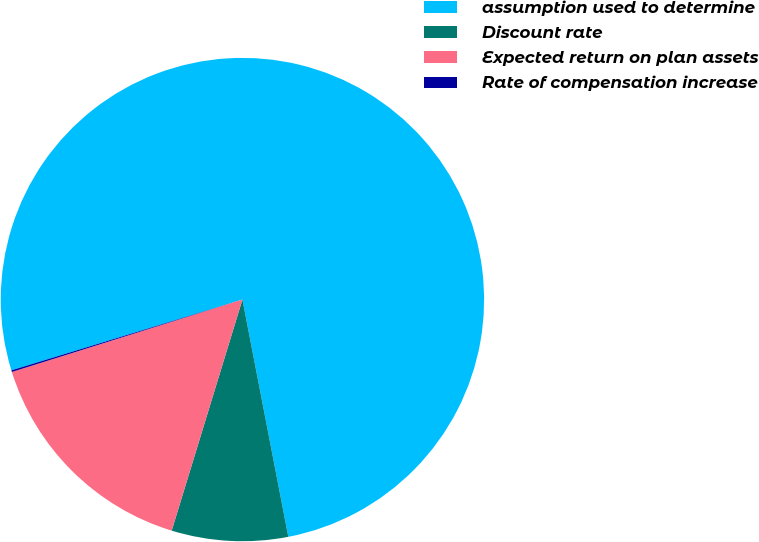Convert chart. <chart><loc_0><loc_0><loc_500><loc_500><pie_chart><fcel>assumption used to determine<fcel>Discount rate<fcel>Expected return on plan assets<fcel>Rate of compensation increase<nl><fcel>76.7%<fcel>7.77%<fcel>15.43%<fcel>0.11%<nl></chart> 